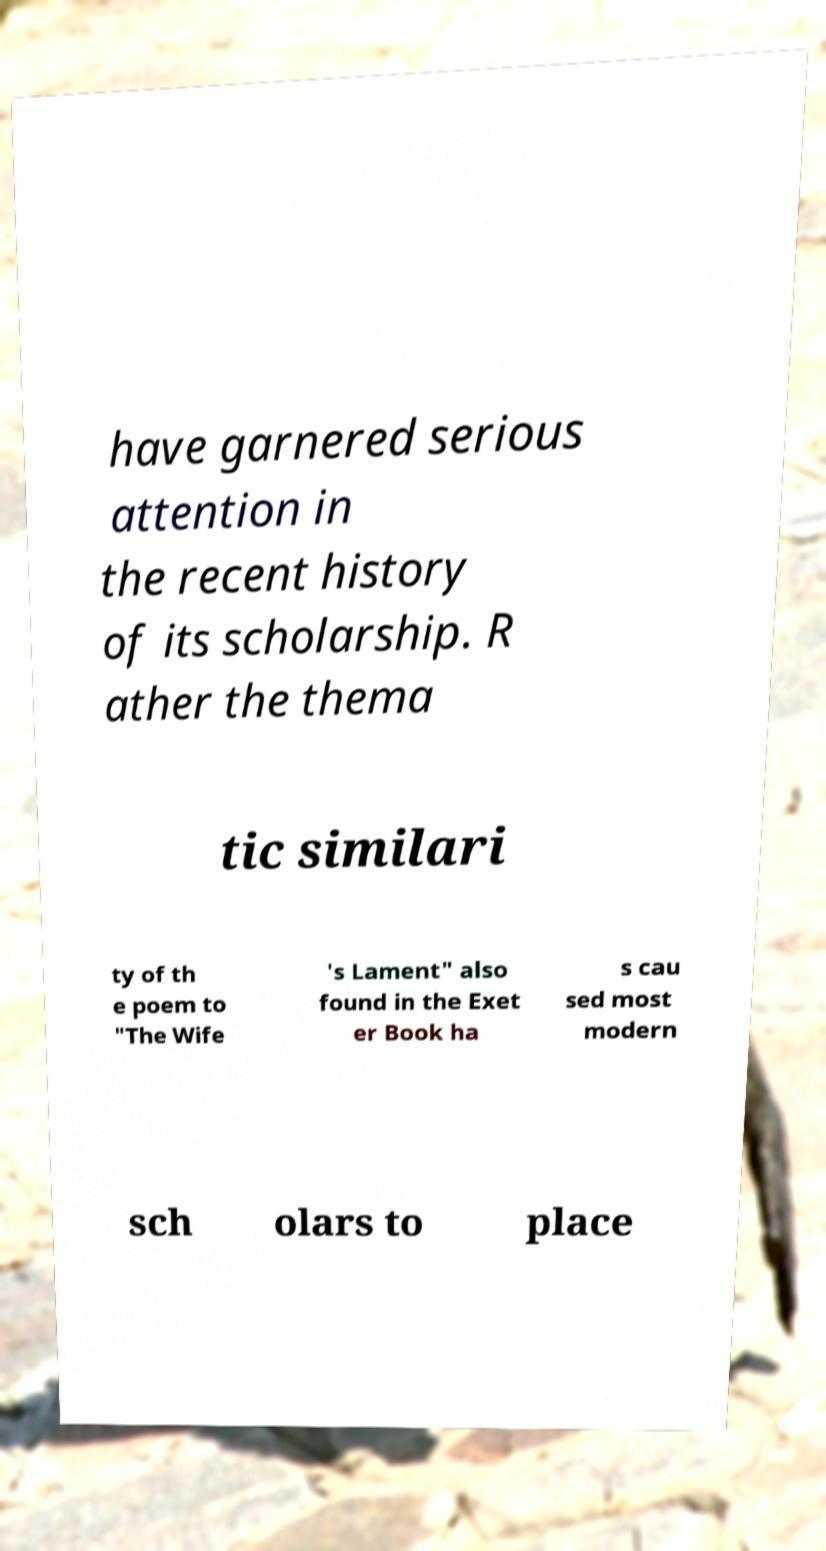Could you extract and type out the text from this image? have garnered serious attention in the recent history of its scholarship. R ather the thema tic similari ty of th e poem to "The Wife 's Lament" also found in the Exet er Book ha s cau sed most modern sch olars to place 